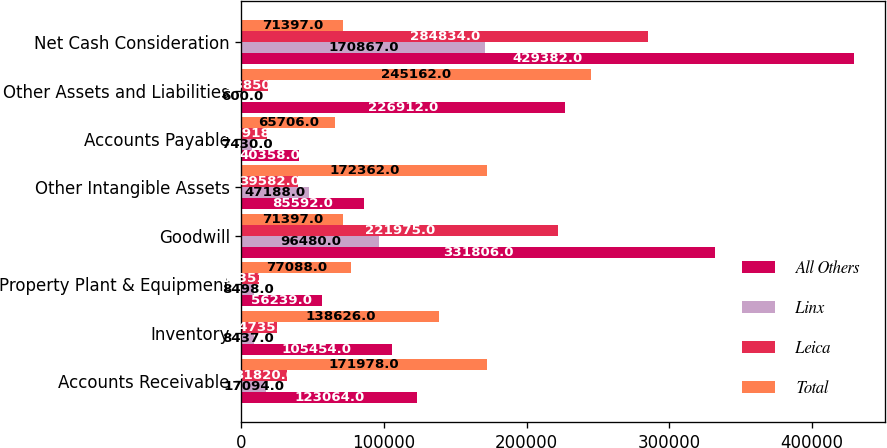Convert chart to OTSL. <chart><loc_0><loc_0><loc_500><loc_500><stacked_bar_chart><ecel><fcel>Accounts Receivable<fcel>Inventory<fcel>Property Plant & Equipment<fcel>Goodwill<fcel>Other Intangible Assets<fcel>Accounts Payable<fcel>Other Assets and Liabilities<fcel>Net Cash Consideration<nl><fcel>All Others<fcel>123064<fcel>105454<fcel>56239<fcel>331806<fcel>85592<fcel>40358<fcel>226912<fcel>429382<nl><fcel>Linx<fcel>17094<fcel>8437<fcel>8498<fcel>96480<fcel>47188<fcel>7430<fcel>600<fcel>170867<nl><fcel>Leica<fcel>31820<fcel>24735<fcel>12351<fcel>221975<fcel>39582<fcel>17918<fcel>18850<fcel>284834<nl><fcel>Total<fcel>171978<fcel>138626<fcel>77088<fcel>71397<fcel>172362<fcel>65706<fcel>245162<fcel>71397<nl></chart> 